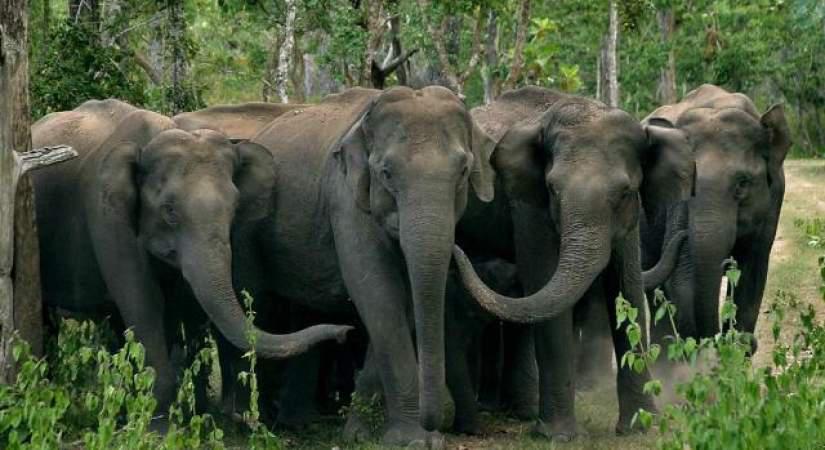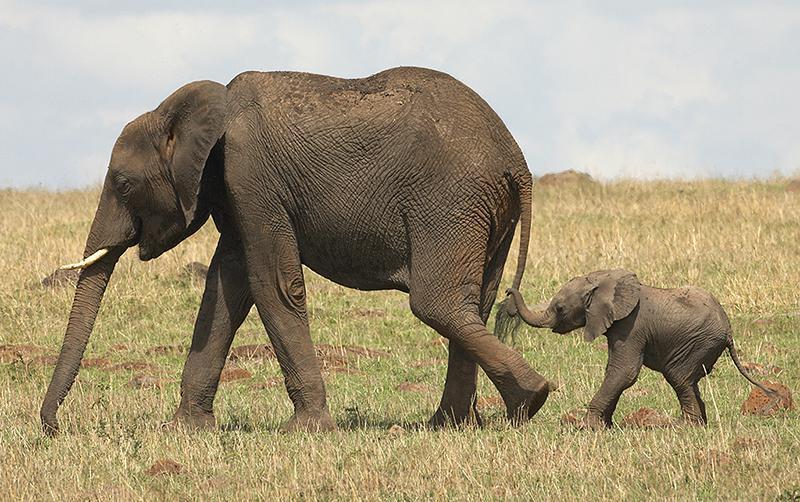The first image is the image on the left, the second image is the image on the right. For the images shown, is this caption "There are no more than three elephants in the image on the right." true? Answer yes or no. Yes. 